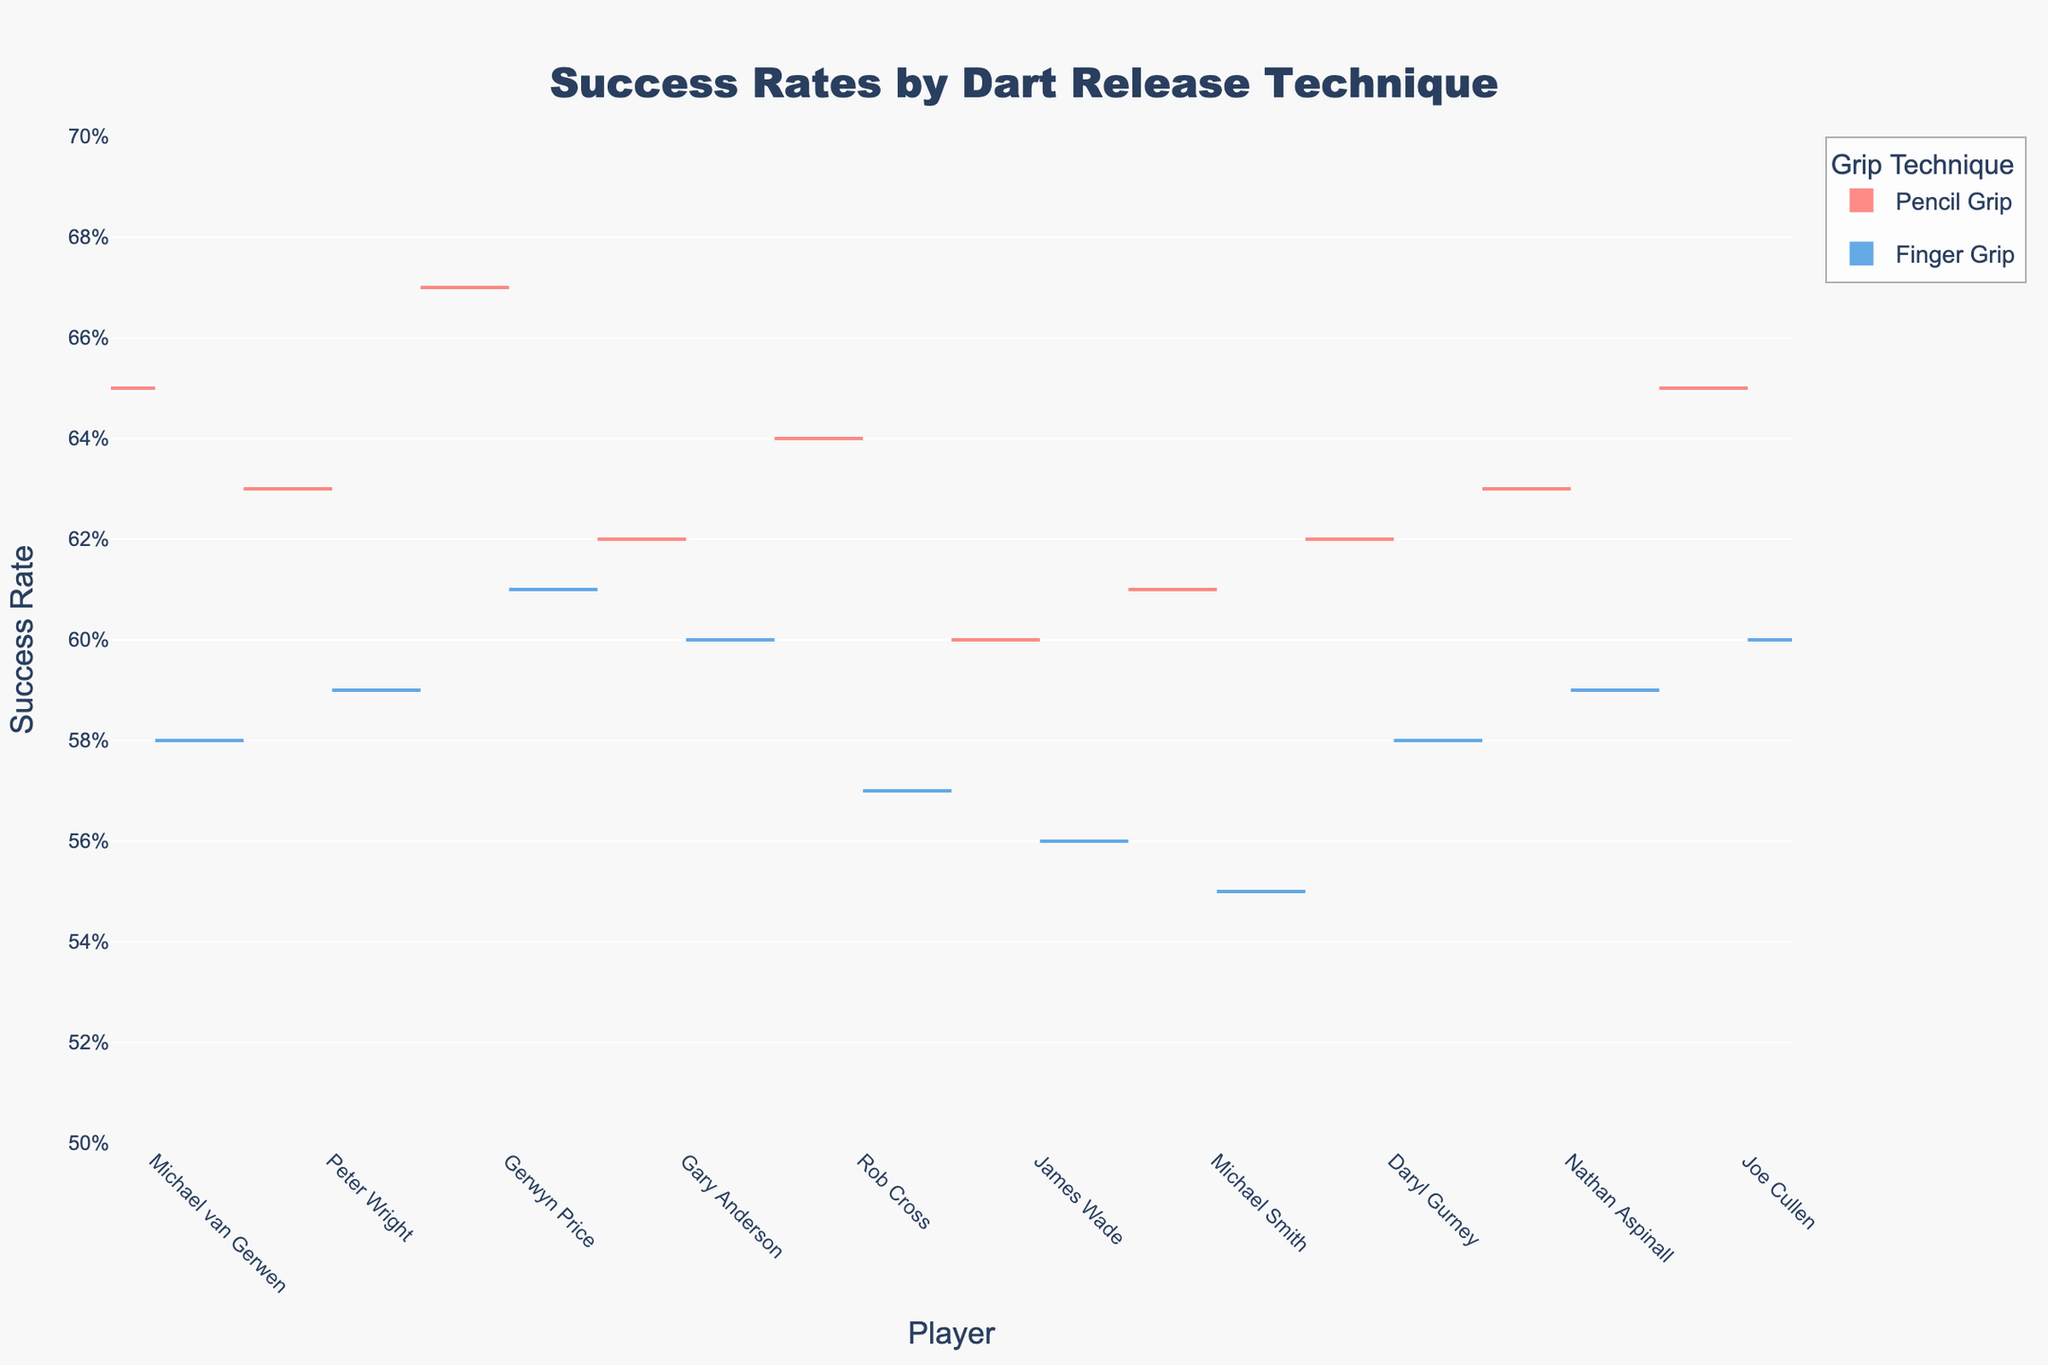What is the title of the chart? The title is located at the top center of the chart and summarizes the content of the chart. It helps viewers quickly understand the subject of the figure.
Answer: Success Rates by Dart Release Technique Which player has the highest success rate with the Pencil Grip? By looking at the left side (negative side) of the split violin chart for each player, we can determine which player's distribution is highest.
Answer: Gerwyn Price How do the success rates compare between the Pencil Grip and Finger Grip for Michael van Gerwen? Locate Michael van Gerwen's section on the x-axis and compare the heights of the portions of the violin plots on each side of his name.
Answer: Pencil Grip is higher Which technique generally results in higher success rates? Observe both sides (left for Pencil Grip and right for Finger Grip) for all players and note which side generally has higher values.
Answer: Pencil Grip What is the average success rate for Finger Grip across all players? Add up all the success rates for Finger Grip and divide by the number of players. The success rates for Finger Grip are: 0.58, 0.59, 0.61, 0.60, 0.57, 0.56, 0.55, 0.58, 0.59, 0.60.
Answer: (0.58 + 0.59 + 0.61 + 0.60 + 0.57 + 0.56 + 0.55 + 0.58 + 0.59 + 0.60) / 10 = 5.93/10 = 0.593 How does James Wade's success with the Finger Grip compare with Peter Wright's Pencil Grip? Look at both James Wade's section for the Finger Grip on the positive side and Peter Wright's section for the Pencil Grip on the negative side, and compare the values.
Answer: Peter Wright's Pencil Grip is higher Describe the color scheme of the chart. Identify the colors used for each technique in the violin chart. The left-side (negative) violins represent one grip, and the right-side (positive) violins represent the other grip.
Answer: Pencil Grip is red, Finger Grip is blue What is the range of success rates for Pencil Grip? Examine the y-axis limits and the distribution of Pencil Grip success rates to determine the lowest and highest values.
Answer: 0.60 to 0.67 How consistent are the success rates for each technique? Look at the spread and density of the violin plots for each technique on each player's section to assess consistency. A wider and more spread-out shape indicates less consistency, while a narrower shape indicates more consistency.
Answer: Finger Grip tends to be less consistent Which player exhibits the smallest difference between the two techniques? Calculate the difference in success rates between Pencil Grip and Finger Grip for each player and identify the smallest difference. Differences: Michael van Gerwen (0.65 - 0.58 = 0.07), Peter Wright (0.63 - 0.59 = 0.04), Gerwyn Price (0.67 - 0.61 = 0.06), Gary Anderson (0.62 - 0.60 = 0.02), Rob Cross (0.64 - 0.57 = 0.07), James Wade (0.60 - 0.56 = 0.04), Michael Smith (0.61 - 0.55 = 0.06), Daryl Gurney (0.62 - 0.58 = 0.04), Nathan Aspinall (0.63 - 0.59 = 0.04), Joe Cullen (0.65 - 0.60 = 0.05).
Answer: Gary Anderson 